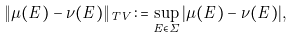<formula> <loc_0><loc_0><loc_500><loc_500>\| \mu ( E ) - \nu ( E ) \| _ { T V } \colon = \sup _ { E \in \Sigma } | \mu ( E ) - \nu ( E ) | ,</formula> 